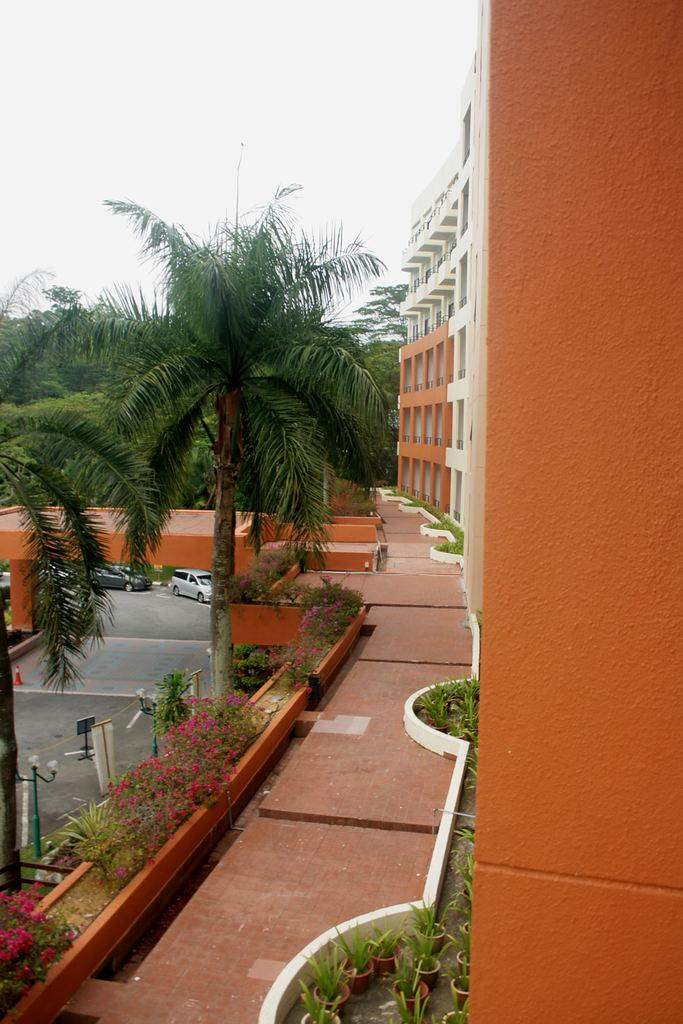What type of structure is visible in the image? There is a building in the image. What other natural elements can be seen in the image? There are trees in the image. What type of vegetation is present at the bottom of the image? Shrubs and plants are present at the bottom of the image. What type of vehicles can be seen in the image? Cars are visible in the image. What is visible in the background of the image? The sky is visible in the background of the image. What is the value of the cause of digestion in the image? There is no mention of digestion or a cause in the image, so it is not possible to determine its value. 